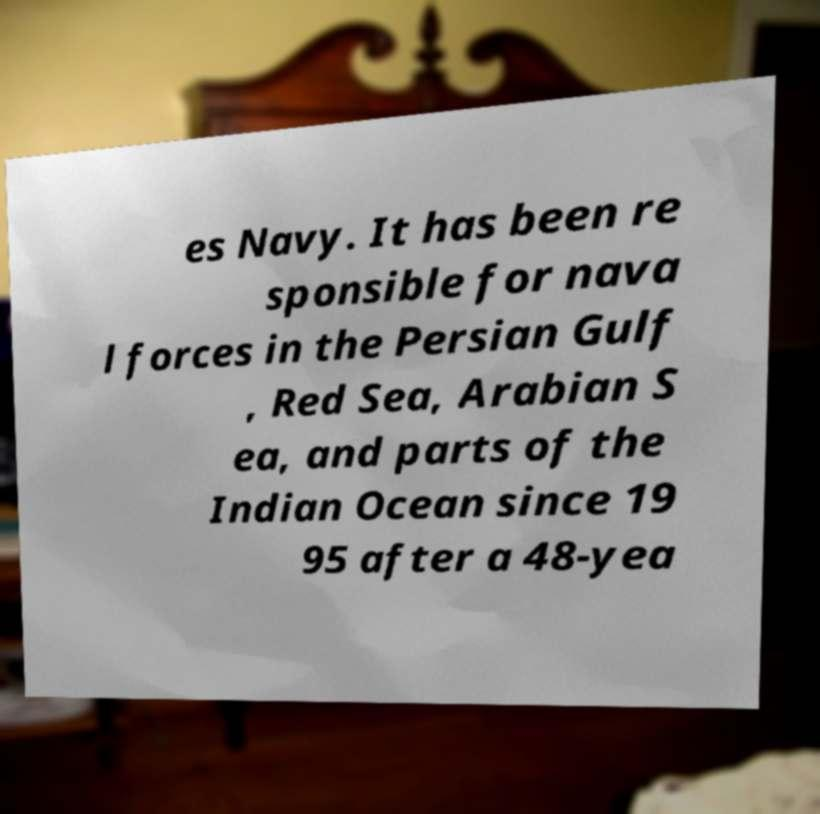There's text embedded in this image that I need extracted. Can you transcribe it verbatim? es Navy. It has been re sponsible for nava l forces in the Persian Gulf , Red Sea, Arabian S ea, and parts of the Indian Ocean since 19 95 after a 48-yea 